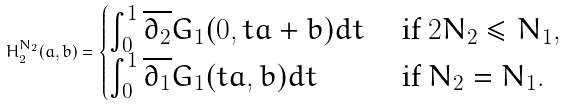<formula> <loc_0><loc_0><loc_500><loc_500>H _ { 2 } ^ { N _ { 2 } } ( a , b ) = \begin{cases} \int _ { 0 } ^ { 1 } \overline { \partial _ { 2 } } G _ { 1 } ( 0 , t a + b ) d t & \text { if $2N_{2}\leq N_{1}$} , \\ \int _ { 0 } ^ { 1 } \overline { \partial _ { 1 } } G _ { 1 } ( t a , b ) d t & \text { if $N_{2}=N_{1}$} . \end{cases}</formula> 